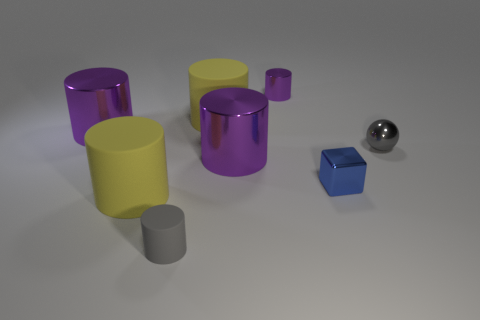Subtract all yellow cylinders. How many cylinders are left? 4 Add 1 large red shiny cylinders. How many objects exist? 9 Subtract all red blocks. How many yellow cylinders are left? 2 Subtract all cylinders. How many objects are left? 2 Subtract 5 cylinders. How many cylinders are left? 1 Subtract all gray cylinders. How many cylinders are left? 5 Subtract all gray metallic things. Subtract all shiny cylinders. How many objects are left? 4 Add 3 blocks. How many blocks are left? 4 Add 5 metal objects. How many metal objects exist? 10 Subtract 0 yellow spheres. How many objects are left? 8 